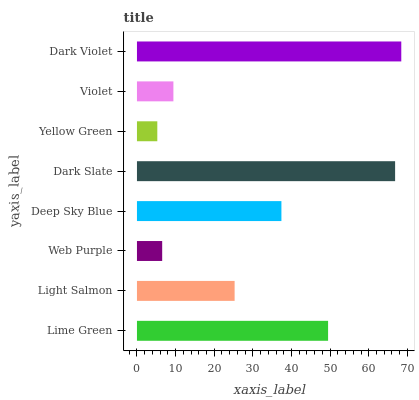Is Yellow Green the minimum?
Answer yes or no. Yes. Is Dark Violet the maximum?
Answer yes or no. Yes. Is Light Salmon the minimum?
Answer yes or no. No. Is Light Salmon the maximum?
Answer yes or no. No. Is Lime Green greater than Light Salmon?
Answer yes or no. Yes. Is Light Salmon less than Lime Green?
Answer yes or no. Yes. Is Light Salmon greater than Lime Green?
Answer yes or no. No. Is Lime Green less than Light Salmon?
Answer yes or no. No. Is Deep Sky Blue the high median?
Answer yes or no. Yes. Is Light Salmon the low median?
Answer yes or no. Yes. Is Light Salmon the high median?
Answer yes or no. No. Is Dark Violet the low median?
Answer yes or no. No. 